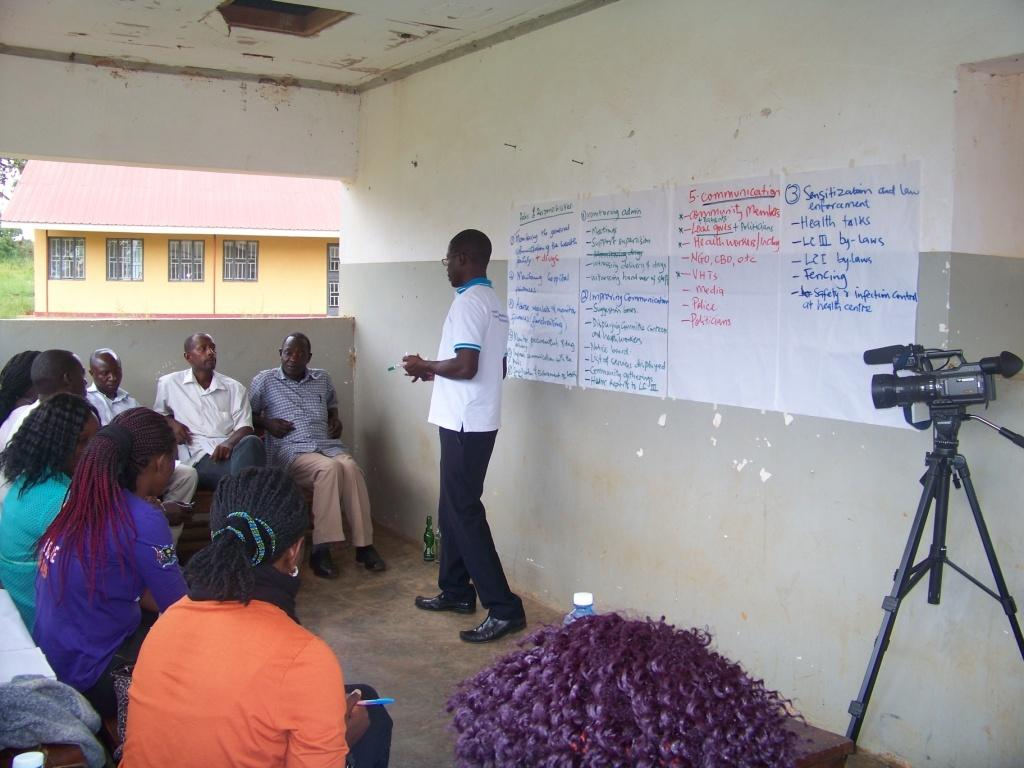What is the color of the wall in the image? The wall in the image is white. What object can be seen in the image that is used for capturing images? There is a camera in the image. What items are present in the image that appear to be for writing or reading? There are papers in the image. What are the people in the image doing? The people in the image are sitting on chairs. What type of building can be seen in the image? There is a house in the image. How many tin quince chickens are present in the image? There are no tin quince chickens present in the image. What type of fruit is being used as a decoration on the wall in the image? There is no fruit being used as a decoration on the wall in the image. 